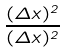<formula> <loc_0><loc_0><loc_500><loc_500>\frac { ( \Delta x ) ^ { 2 } } { ( \Delta x ) ^ { 2 } }</formula> 